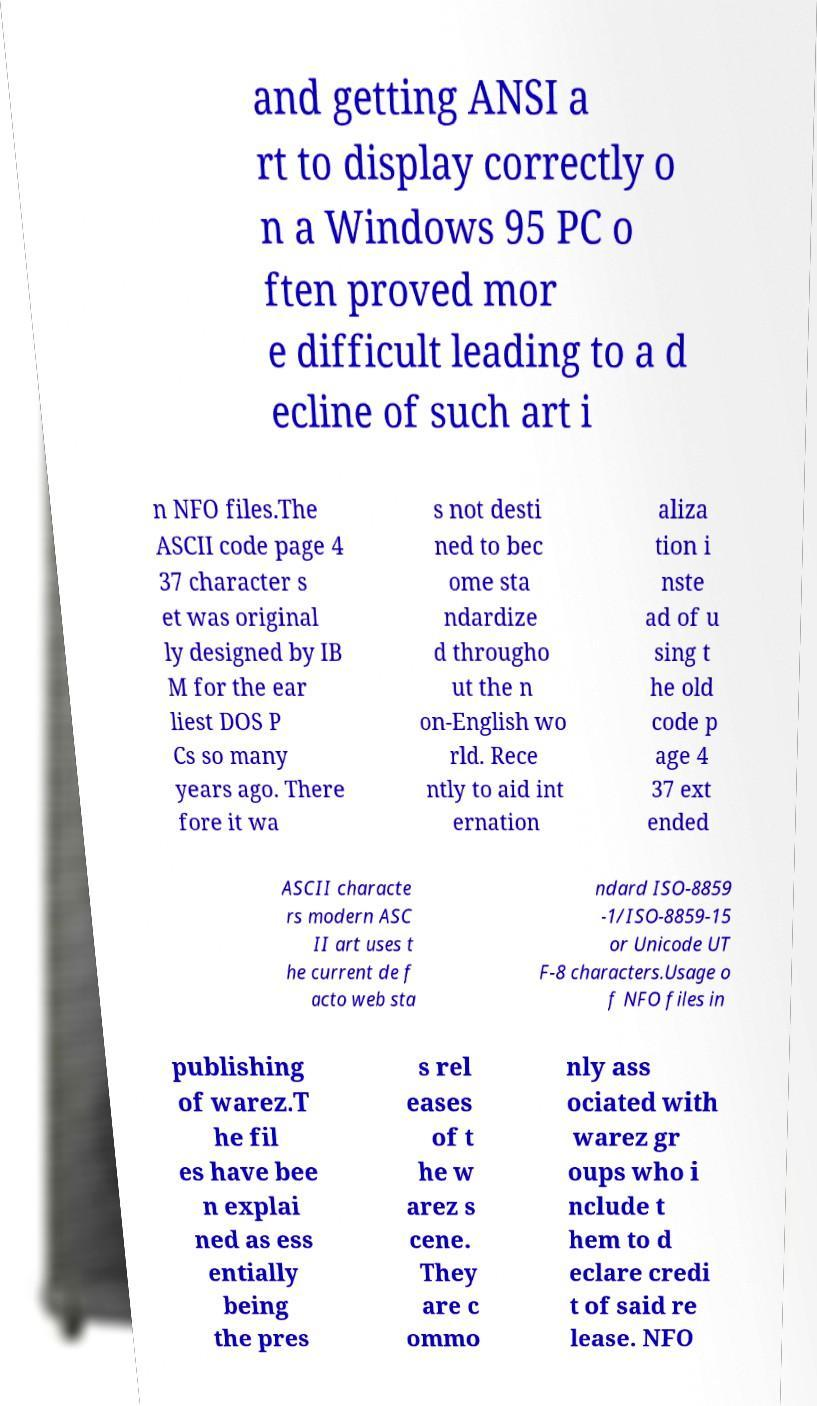For documentation purposes, I need the text within this image transcribed. Could you provide that? and getting ANSI a rt to display correctly o n a Windows 95 PC o ften proved mor e difficult leading to a d ecline of such art i n NFO files.The ASCII code page 4 37 character s et was original ly designed by IB M for the ear liest DOS P Cs so many years ago. There fore it wa s not desti ned to bec ome sta ndardize d througho ut the n on-English wo rld. Rece ntly to aid int ernation aliza tion i nste ad of u sing t he old code p age 4 37 ext ended ASCII characte rs modern ASC II art uses t he current de f acto web sta ndard ISO-8859 -1/ISO-8859-15 or Unicode UT F-8 characters.Usage o f NFO files in publishing of warez.T he fil es have bee n explai ned as ess entially being the pres s rel eases of t he w arez s cene. They are c ommo nly ass ociated with warez gr oups who i nclude t hem to d eclare credi t of said re lease. NFO 